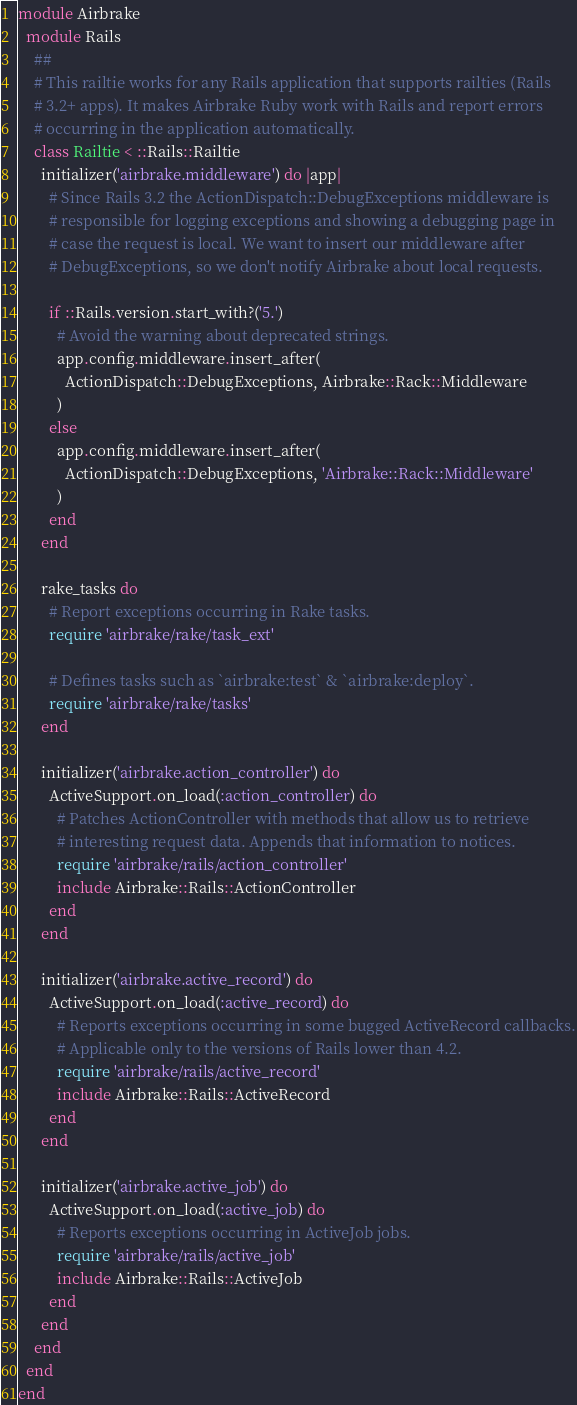<code> <loc_0><loc_0><loc_500><loc_500><_Ruby_>module Airbrake
  module Rails
    ##
    # This railtie works for any Rails application that supports railties (Rails
    # 3.2+ apps). It makes Airbrake Ruby work with Rails and report errors
    # occurring in the application automatically.
    class Railtie < ::Rails::Railtie
      initializer('airbrake.middleware') do |app|
        # Since Rails 3.2 the ActionDispatch::DebugExceptions middleware is
        # responsible for logging exceptions and showing a debugging page in
        # case the request is local. We want to insert our middleware after
        # DebugExceptions, so we don't notify Airbrake about local requests.

        if ::Rails.version.start_with?('5.')
          # Avoid the warning about deprecated strings.
          app.config.middleware.insert_after(
            ActionDispatch::DebugExceptions, Airbrake::Rack::Middleware
          )
        else
          app.config.middleware.insert_after(
            ActionDispatch::DebugExceptions, 'Airbrake::Rack::Middleware'
          )
        end
      end

      rake_tasks do
        # Report exceptions occurring in Rake tasks.
        require 'airbrake/rake/task_ext'

        # Defines tasks such as `airbrake:test` & `airbrake:deploy`.
        require 'airbrake/rake/tasks'
      end

      initializer('airbrake.action_controller') do
        ActiveSupport.on_load(:action_controller) do
          # Patches ActionController with methods that allow us to retrieve
          # interesting request data. Appends that information to notices.
          require 'airbrake/rails/action_controller'
          include Airbrake::Rails::ActionController
        end
      end

      initializer('airbrake.active_record') do
        ActiveSupport.on_load(:active_record) do
          # Reports exceptions occurring in some bugged ActiveRecord callbacks.
          # Applicable only to the versions of Rails lower than 4.2.
          require 'airbrake/rails/active_record'
          include Airbrake::Rails::ActiveRecord
        end
      end

      initializer('airbrake.active_job') do
        ActiveSupport.on_load(:active_job) do
          # Reports exceptions occurring in ActiveJob jobs.
          require 'airbrake/rails/active_job'
          include Airbrake::Rails::ActiveJob
        end
      end
    end
  end
end
</code> 